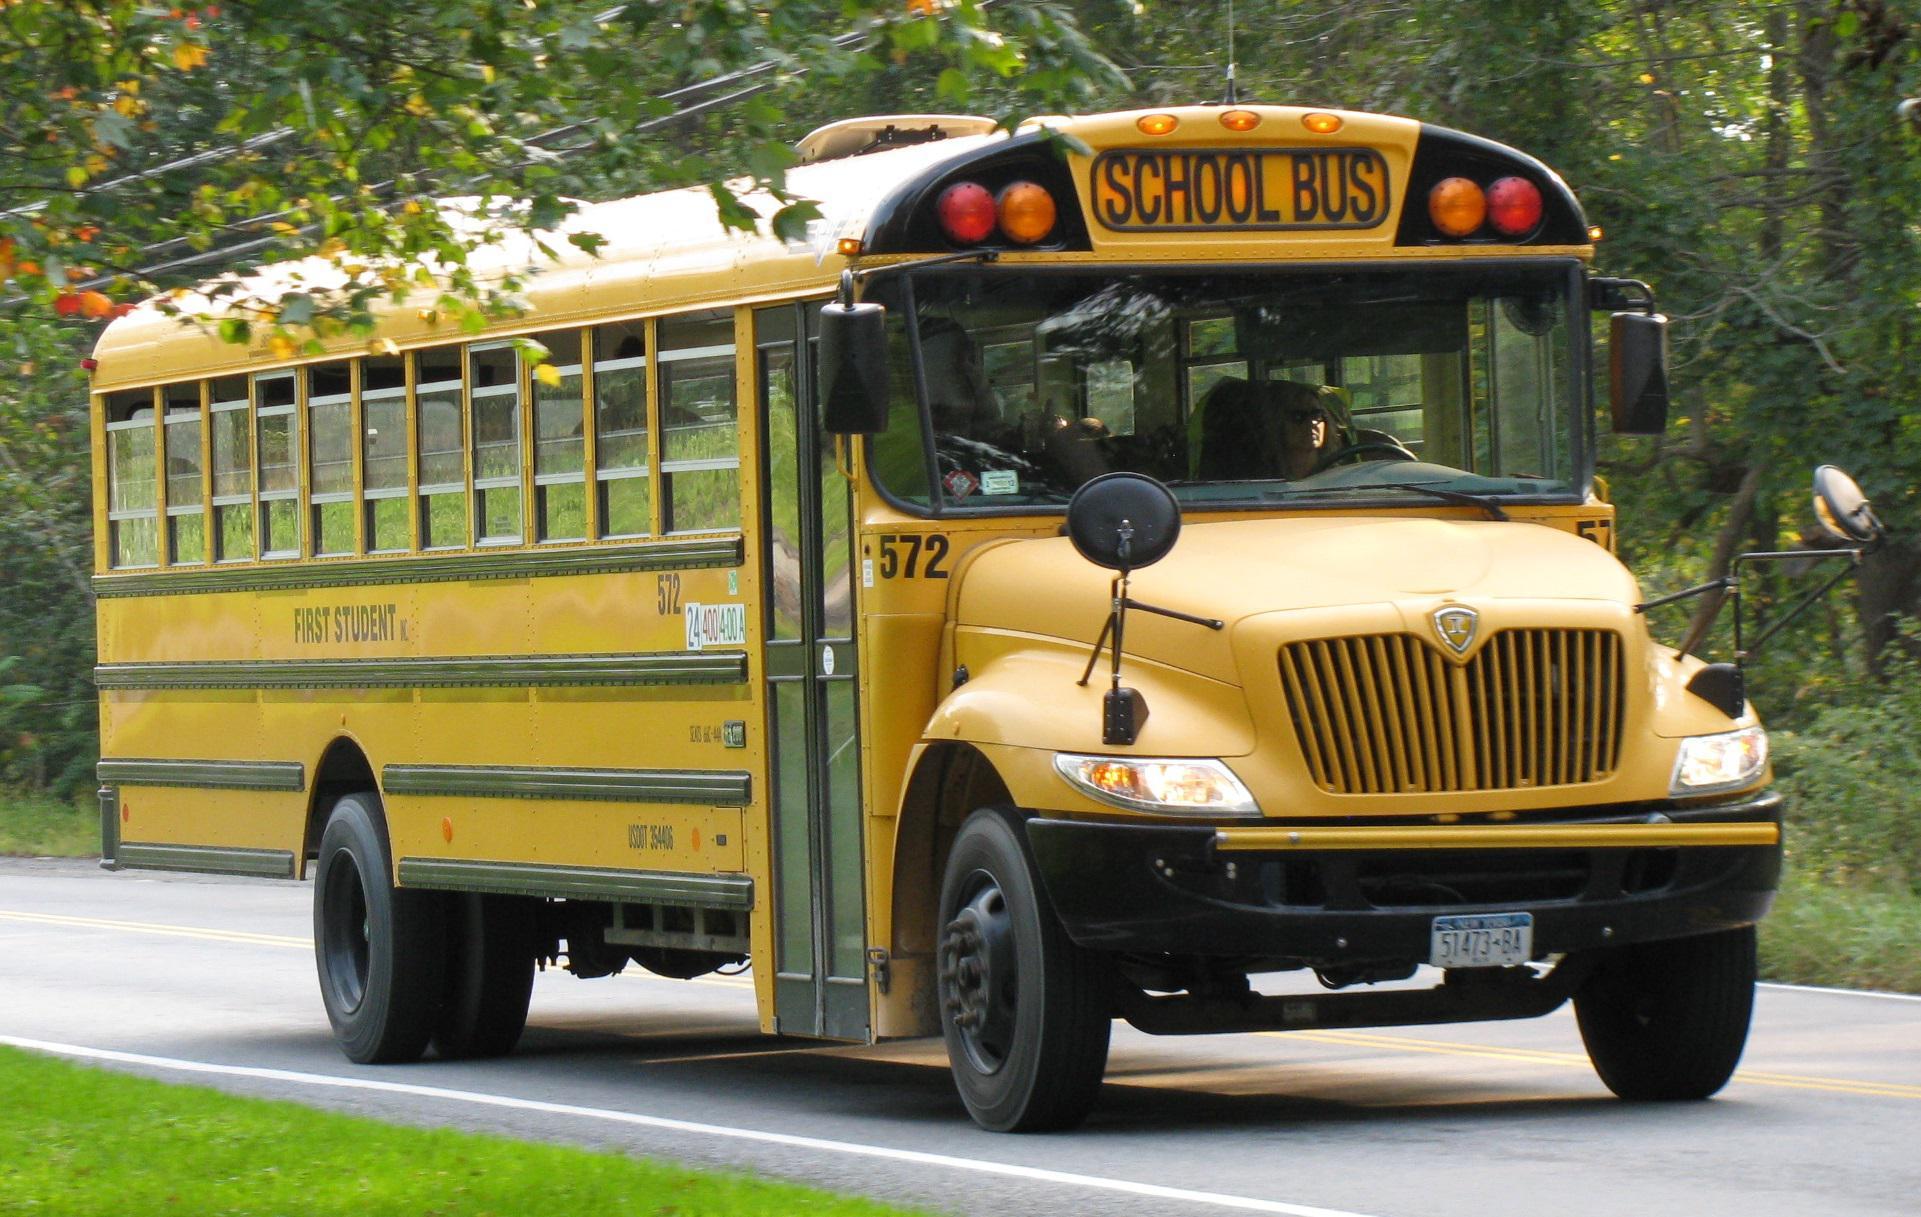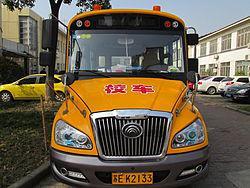The first image is the image on the left, the second image is the image on the right. Examine the images to the left and right. Is the description "The left and right image contains the same number of buses that are facing somewhat forward." accurate? Answer yes or no. Yes. The first image is the image on the left, the second image is the image on the right. Analyze the images presented: Is the assertion "Each image shows a bus with a non-flat front that is facing toward the camera." valid? Answer yes or no. Yes. 